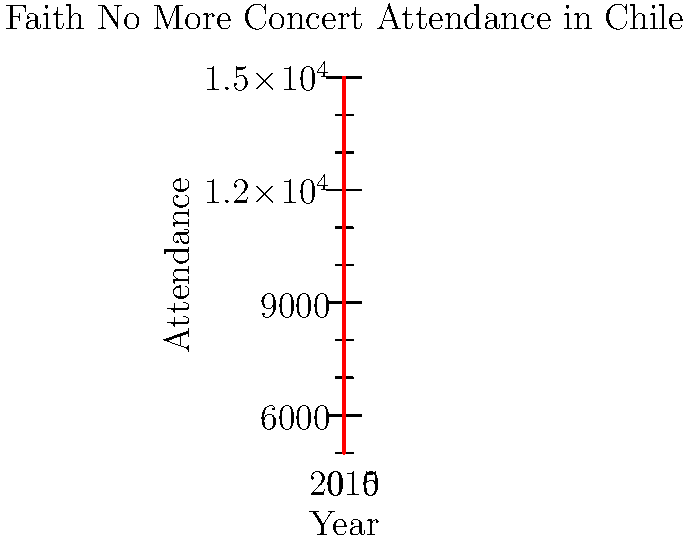Based on the historical attendance data for Faith No More concerts in Chile shown in the graph, what would be the predicted attendance for a concert in 2020 if the trend continues linearly? Assume the venue capacity is 20,000. To predict the attendance for 2020, we need to follow these steps:

1. Observe the trend: The graph shows a linear increase in attendance from 2010 to 2018.

2. Calculate the rate of increase:
   - Attendance in 2010: 5,000
   - Attendance in 2018: 15,000
   - Total increase: 15,000 - 5,000 = 10,000
   - Time span: 2018 - 2010 = 8 years
   - Rate of increase per year: 10,000 / 8 = 1,250 attendees/year

3. Extrapolate to 2020:
   - Years between 2018 and 2020: 2
   - Expected increase: 1,250 * 2 = 2,500
   - Predicted attendance: 15,000 + 2,500 = 17,500

4. Check against venue capacity:
   - Predicted attendance (17,500) < Venue capacity (20,000)

Therefore, the predicted attendance for a Faith No More concert in Chile in 2020, assuming the linear trend continues and the venue can accommodate, would be 17,500 attendees.
Answer: 17,500 attendees 